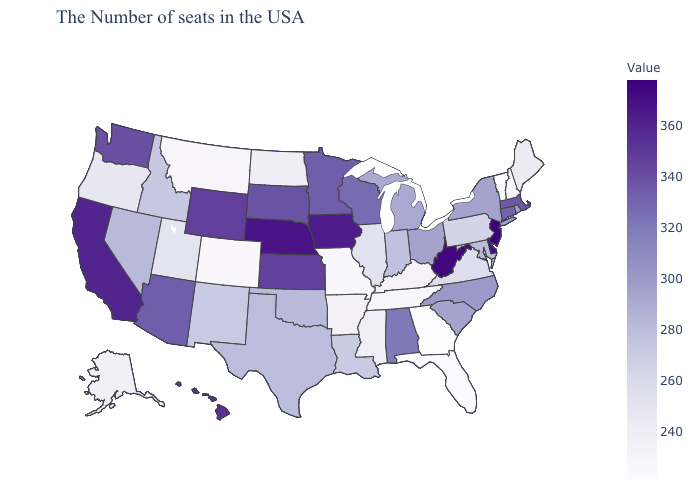Among the states that border New Hampshire , does Vermont have the lowest value?
Be succinct. Yes. Which states hav the highest value in the West?
Short answer required. California. Which states have the highest value in the USA?
Concise answer only. New Jersey. Does Rhode Island have the lowest value in the USA?
Be succinct. No. Among the states that border Idaho , does Oregon have the highest value?
Write a very short answer. No. Is the legend a continuous bar?
Answer briefly. Yes. Among the states that border Wyoming , does Nebraska have the highest value?
Write a very short answer. Yes. 